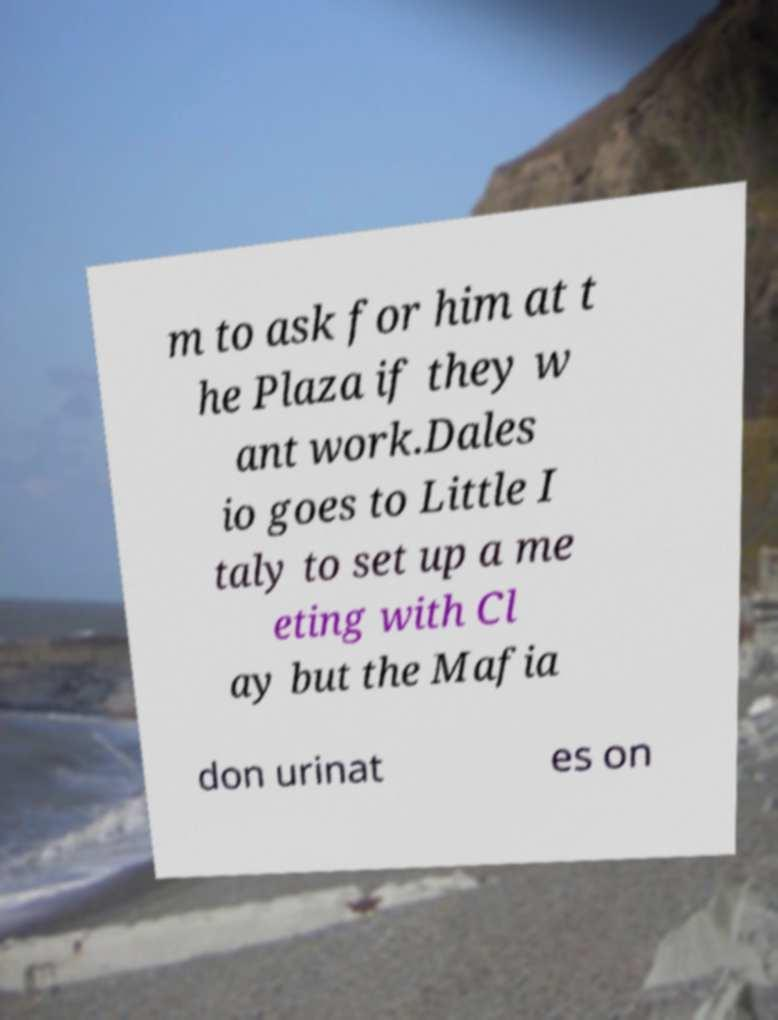There's text embedded in this image that I need extracted. Can you transcribe it verbatim? m to ask for him at t he Plaza if they w ant work.Dales io goes to Little I taly to set up a me eting with Cl ay but the Mafia don urinat es on 